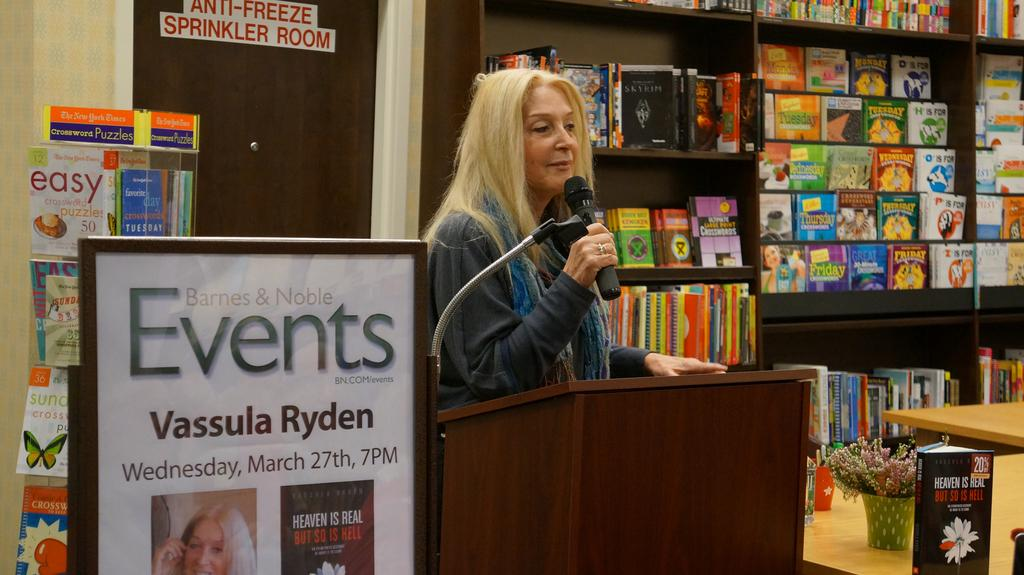<image>
Provide a brief description of the given image. A lady next to a display of a Vassula Ryden event. 